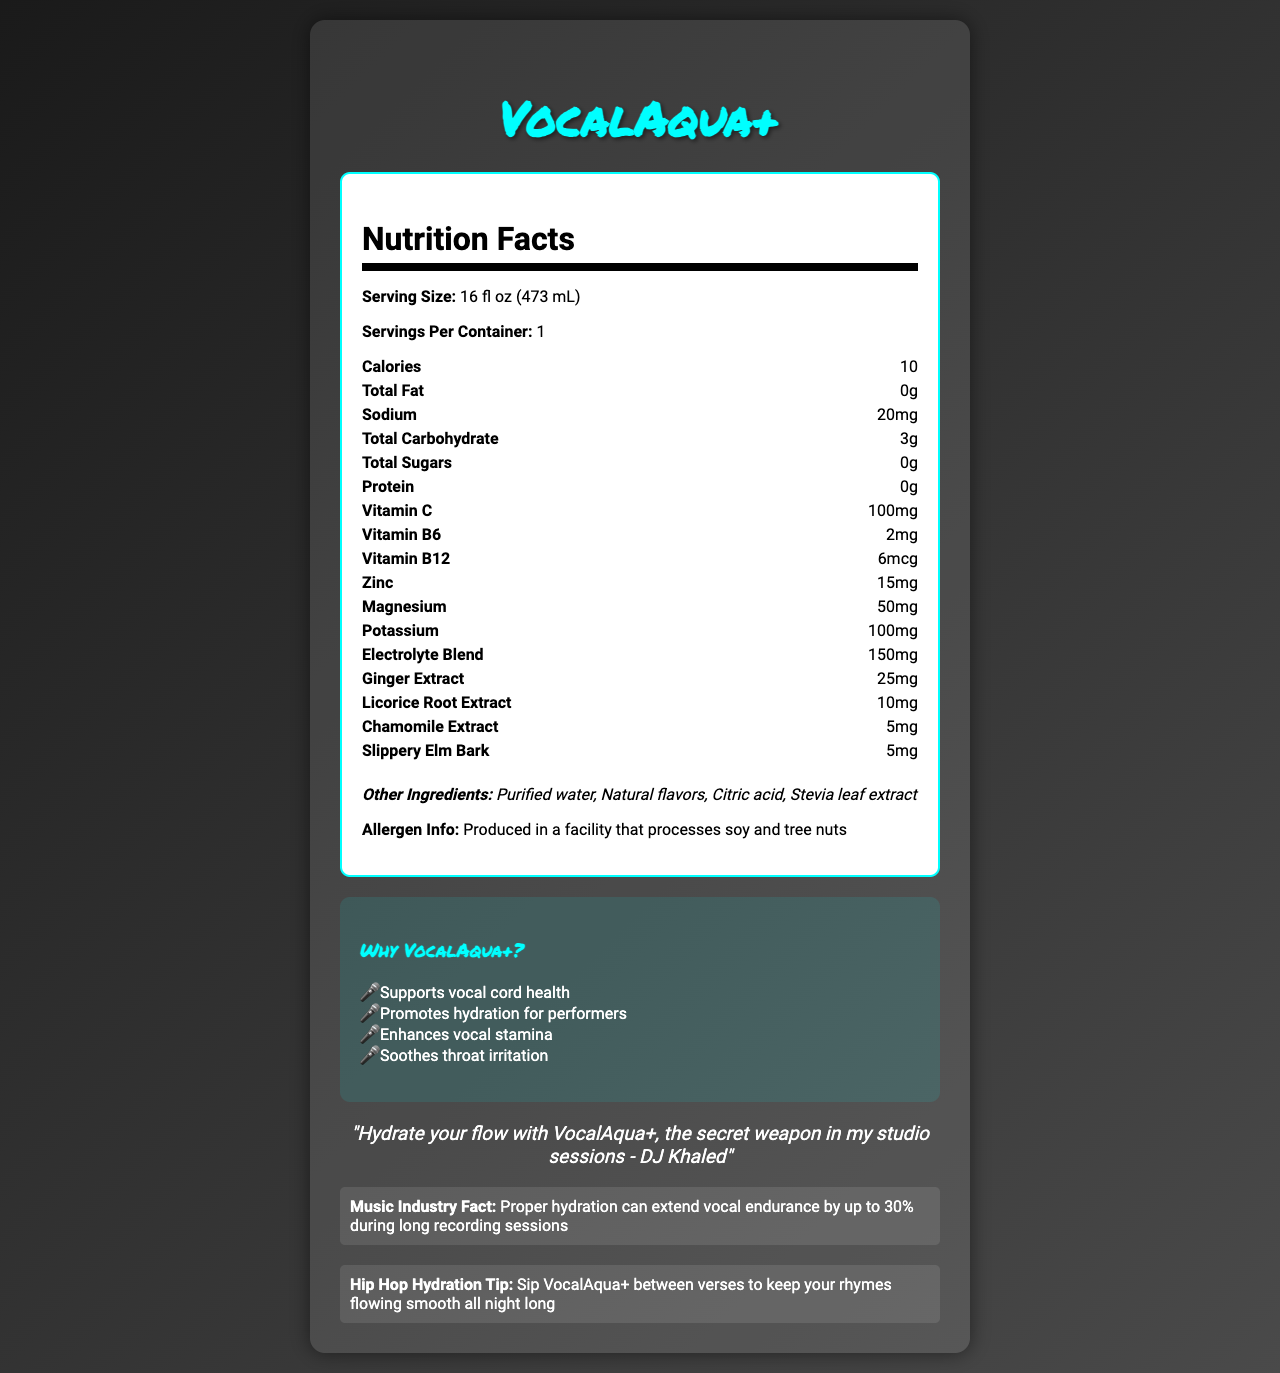what is the serving size of VocalAqua+? The serving size is listed directly under the Nutrition Facts heading.
Answer: 16 fl oz (473 mL) how much sodium is in a serving of VocalAqua+? The amount of sodium is specified in the Nutrition Facts section.
Answer: 20mg how many calories are there per serving of VocalAqua+? The number of calories per serving is stated in the Nutrition Facts section.
Answer: 10 what is the total carbohydrate content in VocalAqua+? The total carbohydrate content is listed in the Nutrition Facts section.
Answer: 3g which vitamins are included in VocalAqua+? The vitamins are mentioned under the Nutrition Facts section, specifically listed as Vitamin C, Vitamin B6, and Vitamin B12.
Answer: Vitamin C, Vitamin B6, Vitamin B12 what is the quantity of zinc in a serving of VocalAqua+? The amount of zinc is shown in the Nutrition Facts section.
Answer: 15mg which ingredient supports vocal cord health according to the document? One of the marketing claims states that the product "Supports vocal cord health," and Licorice Root Extract is known for this benefit.
Answer: Licorice Root Extract which one of these is NOT an ingredient in VocalAqua+? A. Purified water B. Gluten C. Ginger extract D. Stevia leaf extract Gluten is not mentioned in the list of ingredients.
Answer: B. Gluten who endorses VocalAqua+ in the hip-hop industry? A. Eminem B. Jay-Z C. DJ Khaled D. Drake The endorsement quote is attributed to DJ Khaled in the document.
Answer: C. DJ Khaled what is the primary benefit of proper hydration according to the document? A. Extends vocal endurance B. Improves mental clarity C. Enhances muscle recovery D. Increases energy levels The music industry fact states that proper hydration can extend vocal endurance by up to 30% during long recording sessions.
Answer: A. Extends vocal endurance is VocalAqua+ marketed to soothe throat irritation? One of the marketing claims specifically states "Soothes throat irritation."
Answer: Yes summarize the main benefits and claims of VocalAqua+ according to the document. The document highlights various health benefits of VocalAqua+, focusing on hydration and vocal health. It lists the vitamins and minerals included, as well as marketing claims, rapper endorsement, and music industry facts.
Answer: VocalAqua+ is a vitamin-fortified water designed to support vocal cord health, promote hydration for performers, enhance vocal stamina, and soothe throat irritation. It contains essential vitamins and minerals, such as Vitamin C, B6, B12, zinc, magnesium, and potassium, along with specific extracts like ginger and licorice root. It is endorsed by DJ Khaled and claims that proper hydration can extend vocal endurance by up to 30% during long recording sessions. how long can unopened VocalAqua+ be stored? The document does not provide information regarding the shelf life or storage duration of the product.
Answer: Not enough information what are the other ingredients in VocalAqua+ besides vitamins and minerals? These are listed under the "Other Ingredients" section in the Nutrition Facts label.
Answer: Purified water, Natural flavors, Citric acid, Stevia leaf extract 